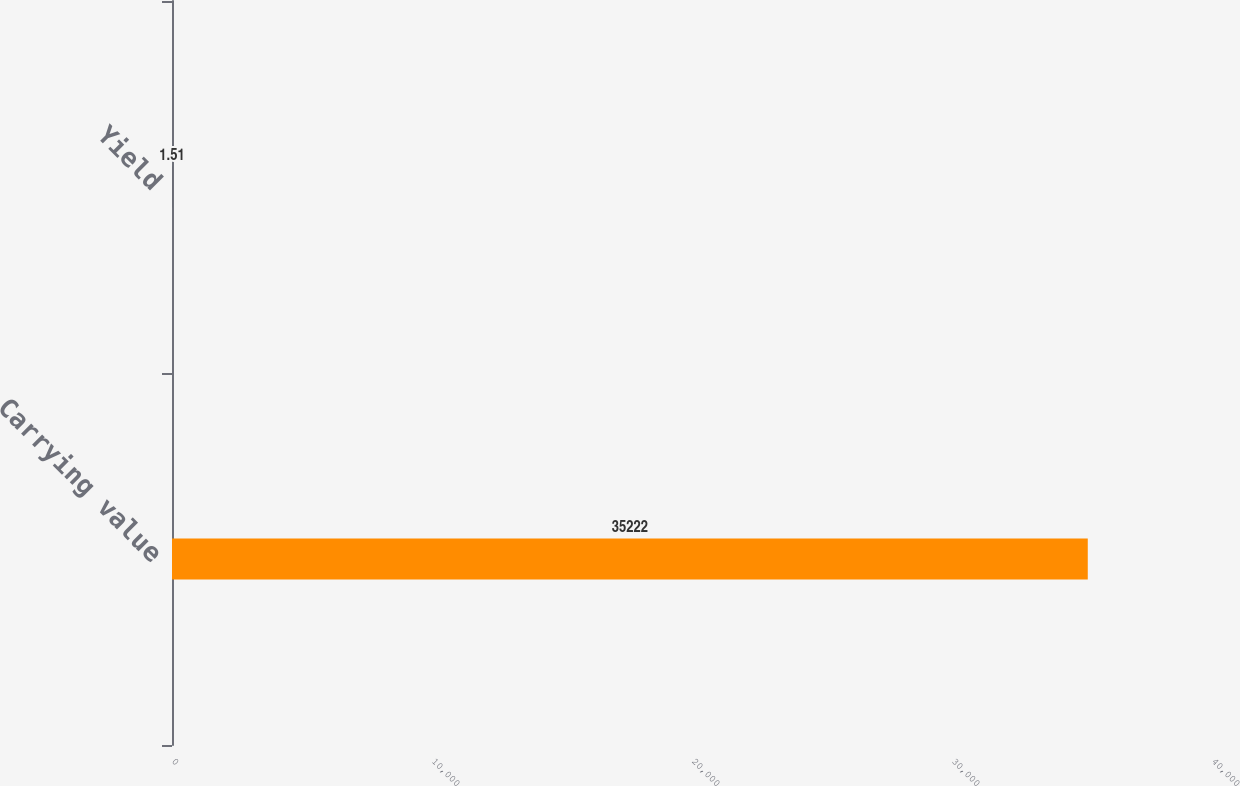Convert chart. <chart><loc_0><loc_0><loc_500><loc_500><bar_chart><fcel>Carrying value<fcel>Yield<nl><fcel>35222<fcel>1.51<nl></chart> 